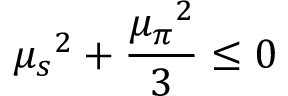<formula> <loc_0><loc_0><loc_500><loc_500>{ \mu _ { s } } ^ { 2 } + \frac { { \mu _ { \pi } } ^ { 2 } } { 3 } \leq 0</formula> 